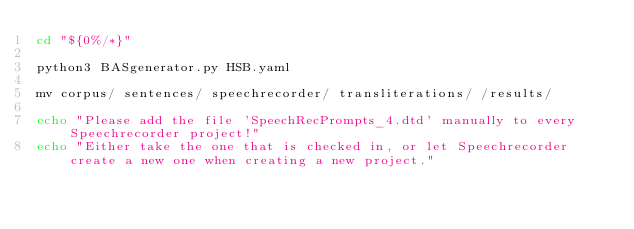<code> <loc_0><loc_0><loc_500><loc_500><_Bash_>cd "${0%/*}"

python3 BASgenerator.py HSB.yaml

mv corpus/ sentences/ speechrecorder/ transliterations/ /results/

echo "Please add the file 'SpeechRecPrompts_4.dtd' manually to every Speechrecorder project!"
echo "Either take the one that is checked in, or let Speechrecorder create a new one when creating a new project."
</code> 